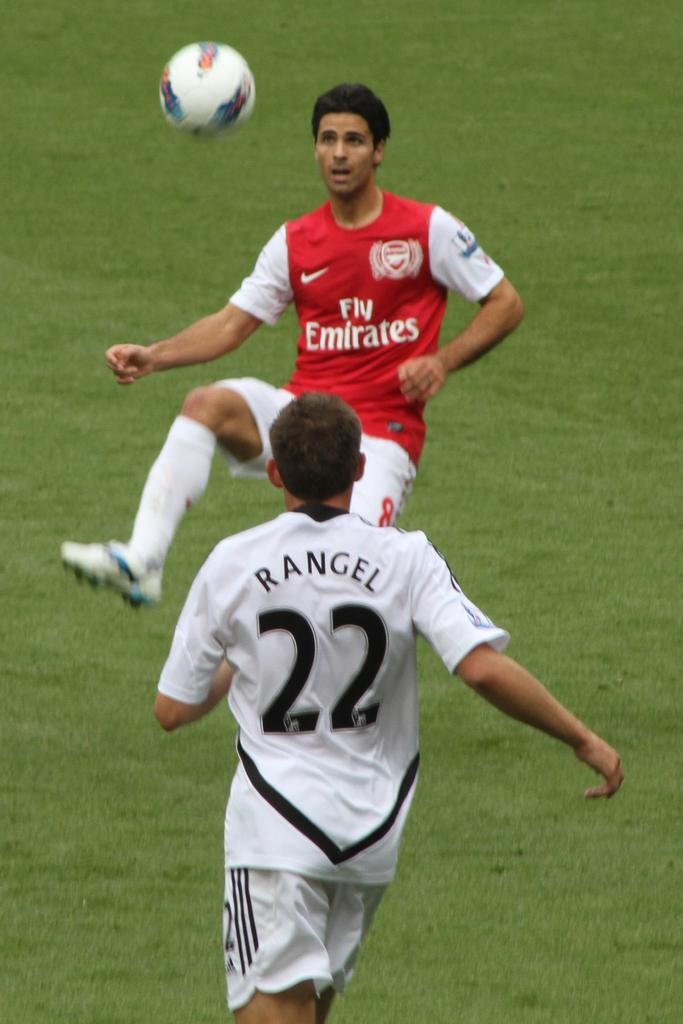<image>
Give a short and clear explanation of the subsequent image. The man wearing the red "Fly Emirates" jersey is preparing to kick the ball. 